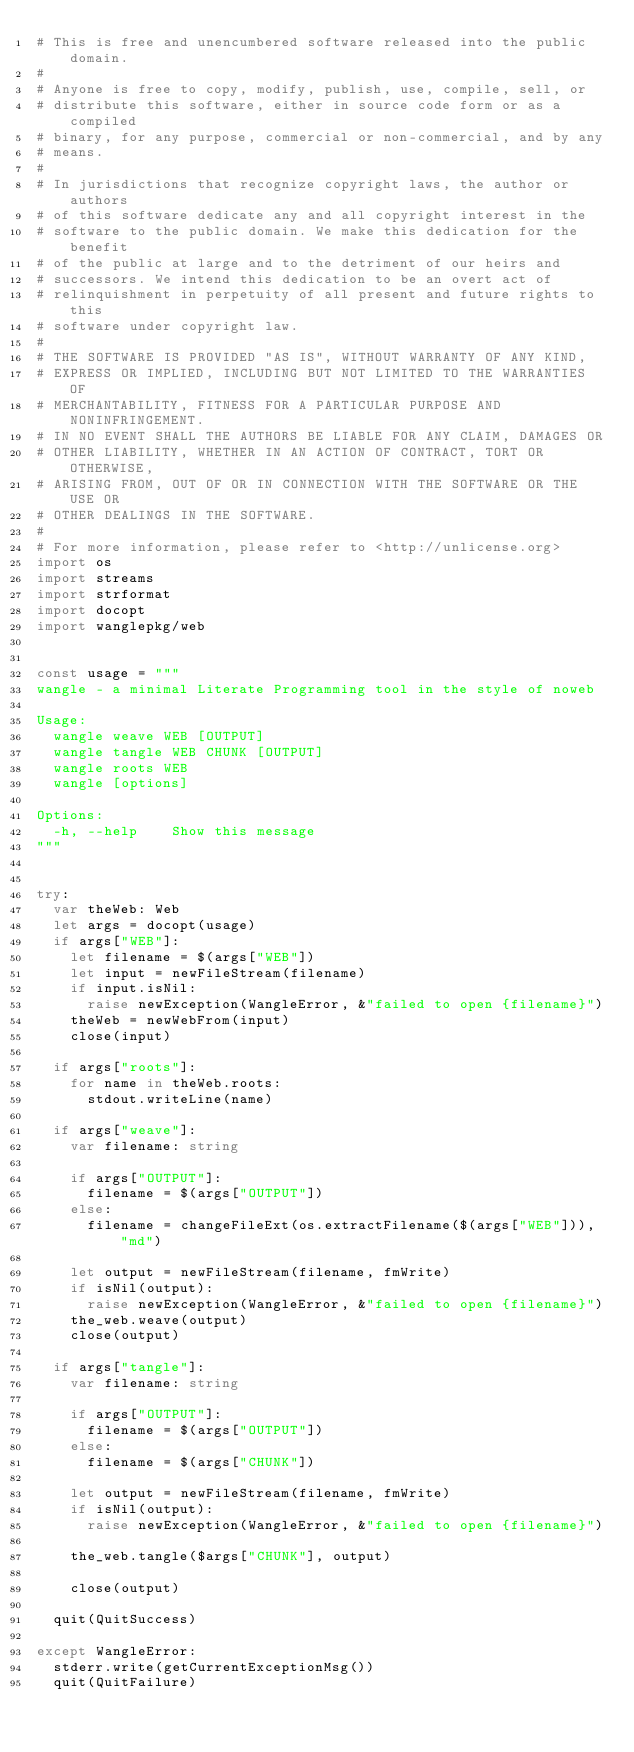Convert code to text. <code><loc_0><loc_0><loc_500><loc_500><_Nim_># This is free and unencumbered software released into the public domain.
# 
# Anyone is free to copy, modify, publish, use, compile, sell, or
# distribute this software, either in source code form or as a compiled
# binary, for any purpose, commercial or non-commercial, and by any
# means.
# 
# In jurisdictions that recognize copyright laws, the author or authors
# of this software dedicate any and all copyright interest in the
# software to the public domain. We make this dedication for the benefit
# of the public at large and to the detriment of our heirs and
# successors. We intend this dedication to be an overt act of
# relinquishment in perpetuity of all present and future rights to this
# software under copyright law.
# 
# THE SOFTWARE IS PROVIDED "AS IS", WITHOUT WARRANTY OF ANY KIND,
# EXPRESS OR IMPLIED, INCLUDING BUT NOT LIMITED TO THE WARRANTIES OF
# MERCHANTABILITY, FITNESS FOR A PARTICULAR PURPOSE AND NONINFRINGEMENT.
# IN NO EVENT SHALL THE AUTHORS BE LIABLE FOR ANY CLAIM, DAMAGES OR
# OTHER LIABILITY, WHETHER IN AN ACTION OF CONTRACT, TORT OR OTHERWISE,
# ARISING FROM, OUT OF OR IN CONNECTION WITH THE SOFTWARE OR THE USE OR
# OTHER DEALINGS IN THE SOFTWARE.
# 
# For more information, please refer to <http://unlicense.org>
import os
import streams
import strformat
import docopt
import wanglepkg/web


const usage = """
wangle - a minimal Literate Programming tool in the style of noweb

Usage:
  wangle weave WEB [OUTPUT]
  wangle tangle WEB CHUNK [OUTPUT]
  wangle roots WEB
  wangle [options]

Options:
  -h, --help    Show this message
"""


try:
  var theWeb: Web
  let args = docopt(usage)
  if args["WEB"]:
    let filename = $(args["WEB"])
    let input = newFileStream(filename)
    if input.isNil:
      raise newException(WangleError, &"failed to open {filename}")
    theWeb = newWebFrom(input)
    close(input)
  
  if args["roots"]:
    for name in theWeb.roots:
      stdout.writeLine(name)
  
  if args["weave"]:
    var filename: string
  
    if args["OUTPUT"]:
      filename = $(args["OUTPUT"])
    else:
      filename = changeFileExt(os.extractFilename($(args["WEB"])), "md")
  
    let output = newFileStream(filename, fmWrite)
    if isNil(output):
      raise newException(WangleError, &"failed to open {filename}")
    the_web.weave(output)
    close(output)
    
  if args["tangle"]:
    var filename: string
  
    if args["OUTPUT"]:
      filename = $(args["OUTPUT"])
    else:
      filename = $(args["CHUNK"])
  
    let output = newFileStream(filename, fmWrite)
    if isNil(output):
      raise newException(WangleError, &"failed to open {filename}")
  
    the_web.tangle($args["CHUNK"], output)
  
    close(output)
    
  quit(QuitSuccess)

except WangleError:
  stderr.write(getCurrentExceptionMsg())
  quit(QuitFailure)
</code> 